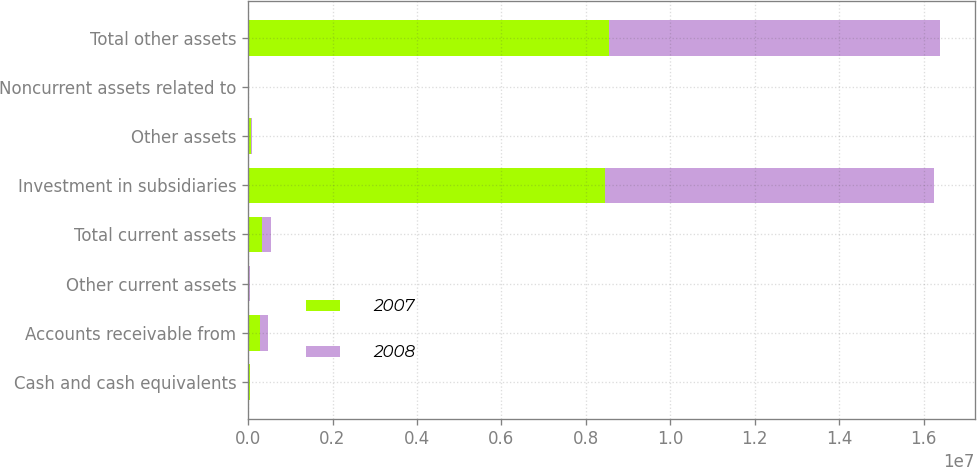Convert chart. <chart><loc_0><loc_0><loc_500><loc_500><stacked_bar_chart><ecel><fcel>Cash and cash equivalents<fcel>Accounts receivable from<fcel>Other current assets<fcel>Total current assets<fcel>Investment in subsidiaries<fcel>Other assets<fcel>Noncurrent assets related to<fcel>Total other assets<nl><fcel>2007<fcel>51778<fcel>275077<fcel>6573<fcel>333428<fcel>8.465e+06<fcel>61675<fcel>15914<fcel>8.54259e+06<nl><fcel>2008<fcel>3161<fcel>187522<fcel>29313<fcel>219996<fcel>7.79057e+06<fcel>40460<fcel>16926<fcel>7.84796e+06<nl></chart> 